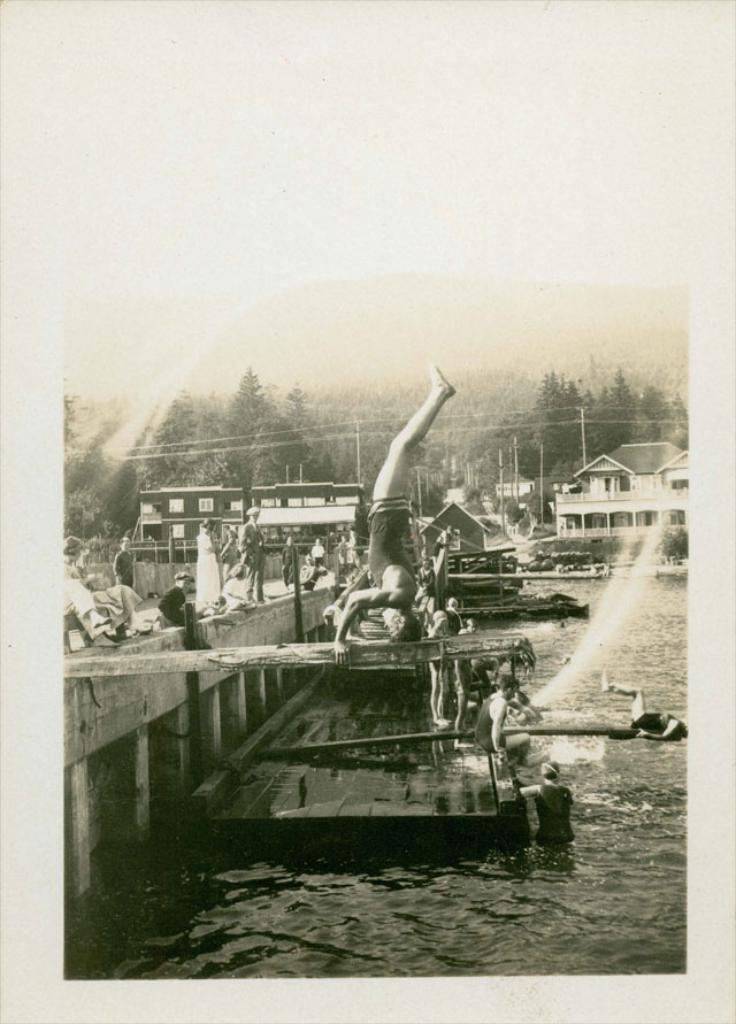In one or two sentences, can you explain what this image depicts? This is a black and white image, in this image at the bottom there is a sea, and in the sea there is some object and there are a group of people and there is a bridge. In the background there are houses, poles, trees and wires. 